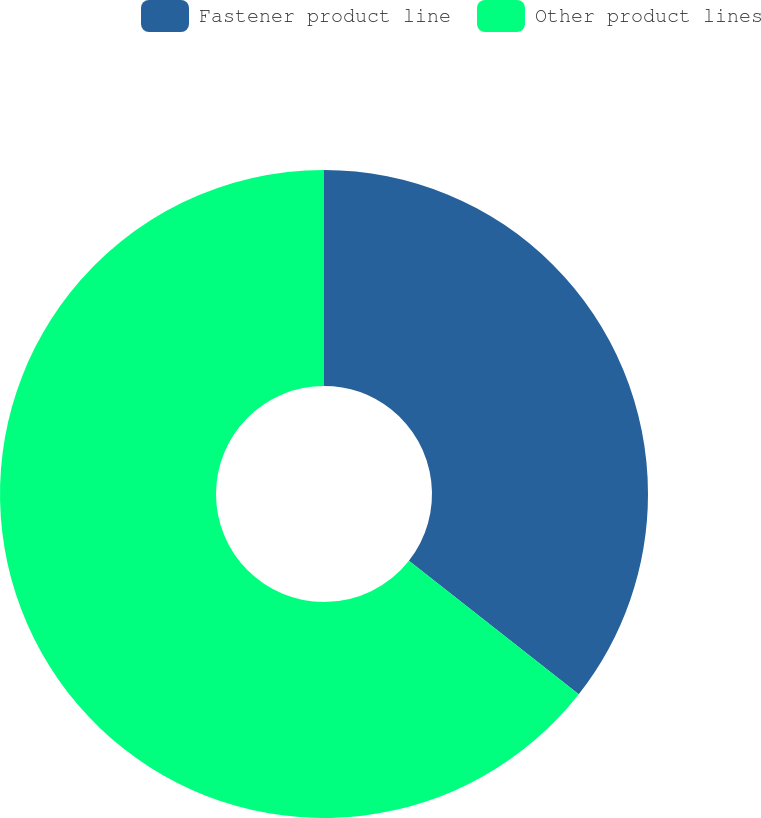<chart> <loc_0><loc_0><loc_500><loc_500><pie_chart><fcel>Fastener product line<fcel>Other product lines<nl><fcel>35.6%<fcel>64.4%<nl></chart> 